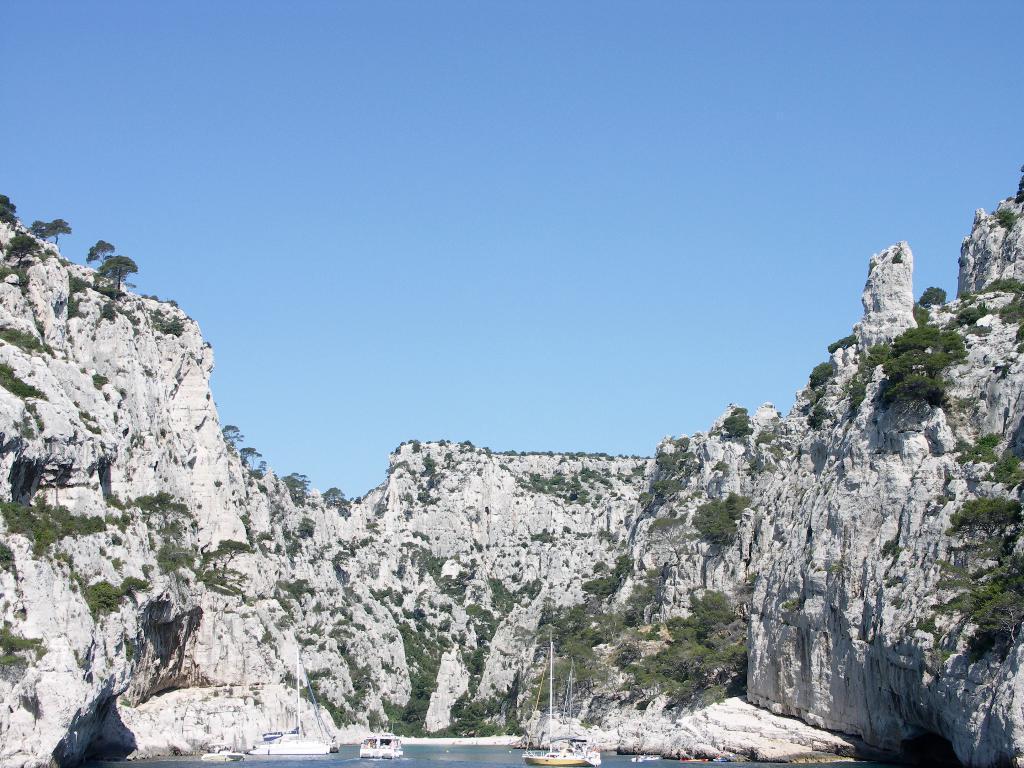Describe this image in one or two sentences. In this image there are some ships on the water, beside that there is a rock mountain with some plants and clear sky. 